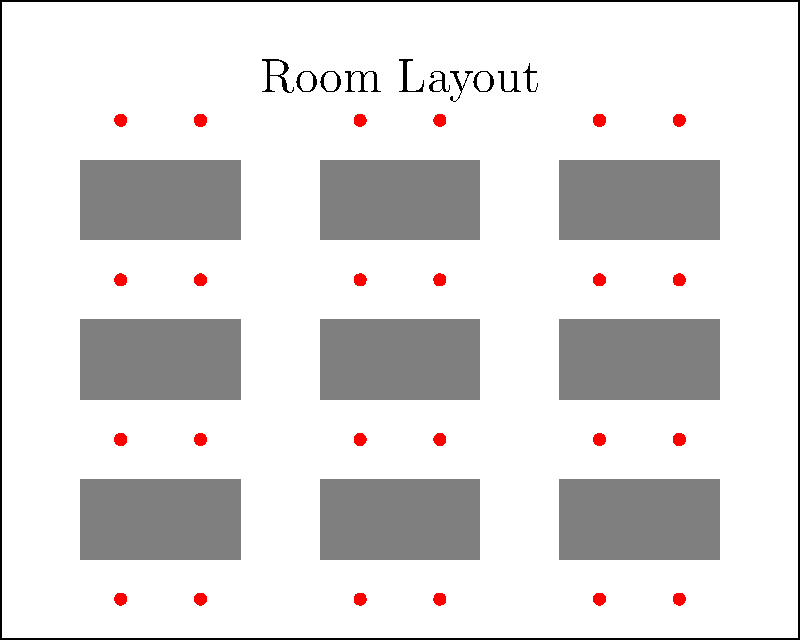As the administrative officer responsible for logistics, you need to arrange a meeting room for negotiations. The room is rectangular, measuring 10 units wide and 8 units long. You have rectangular tables (2x1 units each) and chairs (represented by dots). What is the maximum number of people that can be seated in this configuration if each table accommodates 4 chairs, and there must be at least 1 unit of space between each row of tables for easy movement? To determine the maximum number of people that can be seated, let's follow these steps:

1. Room dimensions: 10 units wide x 8 units long

2. Table arrangement:
   - We can fit 3 tables in each row (3 * 2 units = 6 units wide, leaving 2 units for sides)
   - We can fit 3 rows of tables (3 * 1 unit = 3 units long, plus 2 units for spacing between rows = 5 units, leaving 3 units for top and bottom)

3. Number of tables:
   - 3 tables per row * 3 rows = 9 tables total

4. Seating capacity:
   - Each table accommodates 4 chairs
   - Total chairs = 9 tables * 4 chairs per table = 36 chairs

5. Verify spacing:
   - There is 1 unit of space between each row of tables
   - There is sufficient space on the sides for movement

Therefore, the maximum number of people that can be seated in this configuration is 36.
Answer: 36 people 